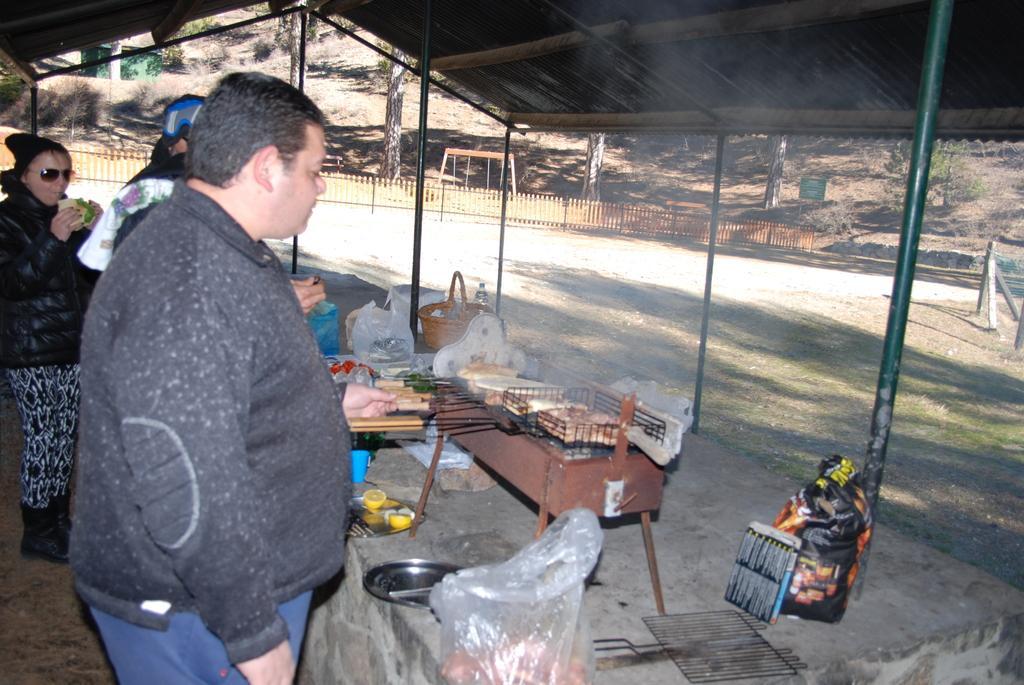In one or two sentences, can you explain what this image depicts? In this picture there are people on the left side of the image, they are grilling and there is grass land on the right side of the image, there is boundary in the center of the image. 